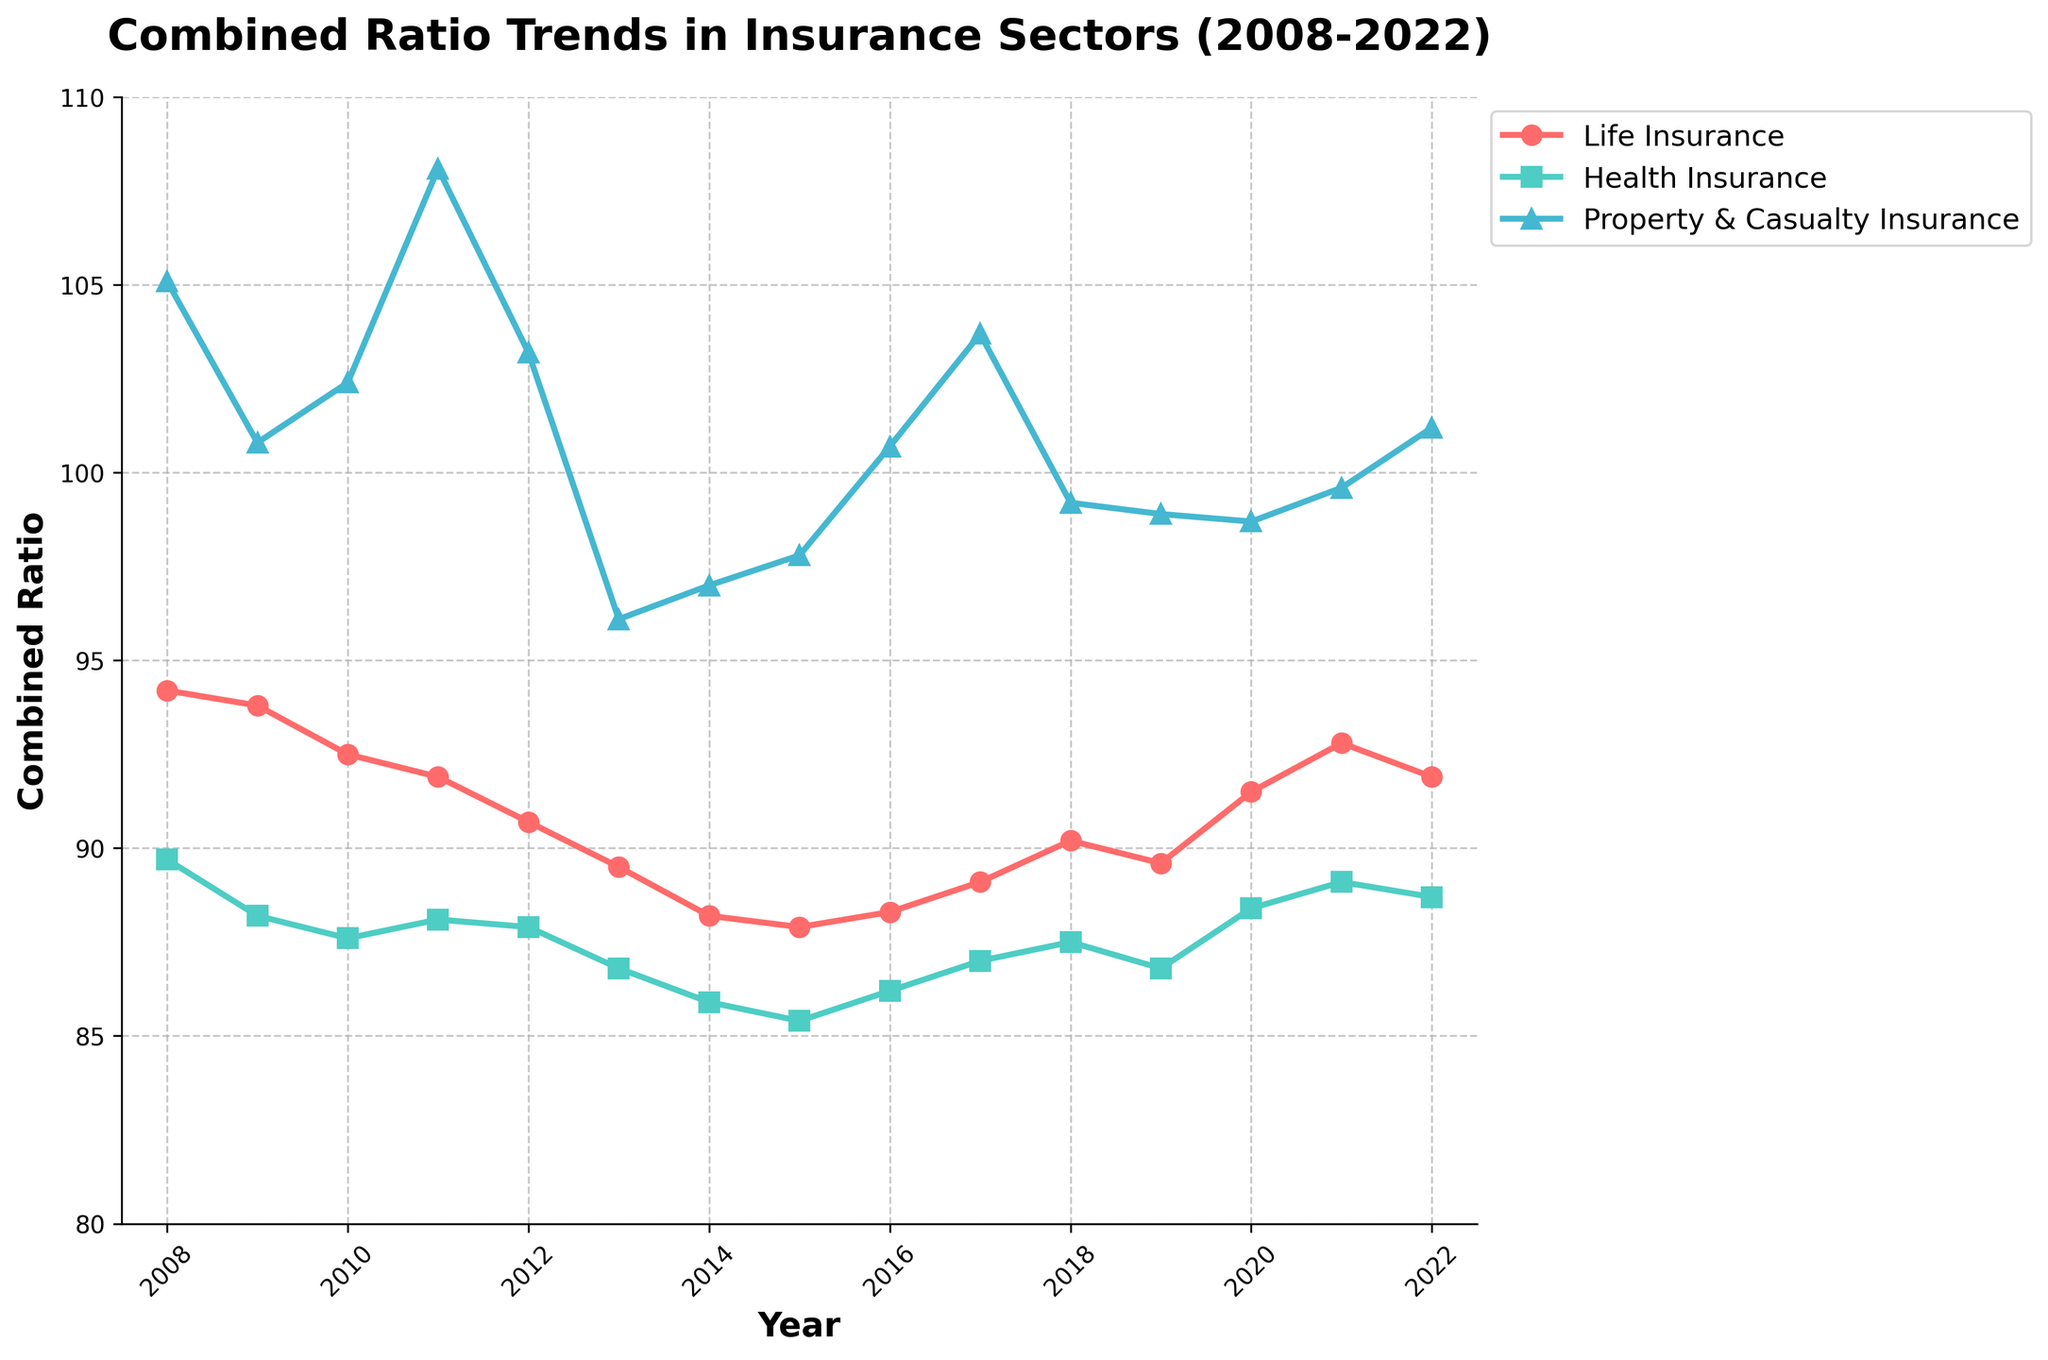What's the trend in the combined ratio for Life Insurance from 2008 to 2022? To determine the trend, observe the line representing Life Insurance. The values generally decrease from 94.2 in 2008 to around 87.9 in 2015, then slightly increase again until 2022.
Answer: Decrease then slight increase How did the combined ratio for Property & Casualty Insurance in 2011 compare to that in 2013? Observing the plot, the combined ratio for Property & Casualty Insurance in 2011 is around 108.1, whereas in 2013 it is around 96.1.
Answer: Higher in 2011 Between Health Insurance and Life Insurance, which had a lower combined ratio in 2022? In 2022, Health Insurance has a combined ratio of 88.7 while Life Insurance has a ratio of 91.9, indicating Health Insurance was lower.
Answer: Health Insurance What is the average combined ratio for Life Insurance in the first five years (2008-2012)? Sum the combined ratios for Life Insurance from 2008 to 2012: (94.2 + 93.8 + 92.5 + 91.9 + 90.7) = 463.1. Divide by 5: 463.1 / 5 = 92.62.
Answer: 92.62 In which year did Health Insurance hit its lowest combined ratio, and what was the value? By observing the Health Insurance curve, the lowest point occurs in 2015 with a value of 85.4.
Answer: 2015, 85.4 Which sector had the most volatile combined ratio trend over the 15 years? Volatility can be inferred from the line's fluctuations. Property & Casualty Insurance shows the most dramatic ups and downs, especially notable peaks and troughs compared to the other sectors.
Answer: Property & Casualty Insurance What's the difference between the highest and lowest combined ratios for Property & Casualty Insurance over the 15 years? The highest combined ratio for Property & Casualty Insurance is 108.1 (2011), and the lowest is 96.1 (2013). The difference is 108.1 - 96.1 = 12.
Answer: 12 What overall trend can be observed in the combined ratios of Health Insurance from 2008 to 2022? The Health Insurance combined ratio starts at 89.7 in 2008 and generally decreases to 85.4 by 2015, then shows a slight upward trend to 88.7 by 2022.
Answer: Decreasing then slight increase Compare the combined ratio trends for Life Insurance and Health Insurance in 2020. In 2020, Life Insurance shows an increasing trend to around 91.5, while Health Insurance also increases to around 88.4.
Answer: Both increasing Across all sectors, which year had the most favorable combined ratios? Favorable combined ratios are generally lower. 2013 seems to be the most favorable overall, with Life Insurance at 89.5, Health Insurance at 86.8, and Property & Casualty at 96.1.
Answer: 2013 